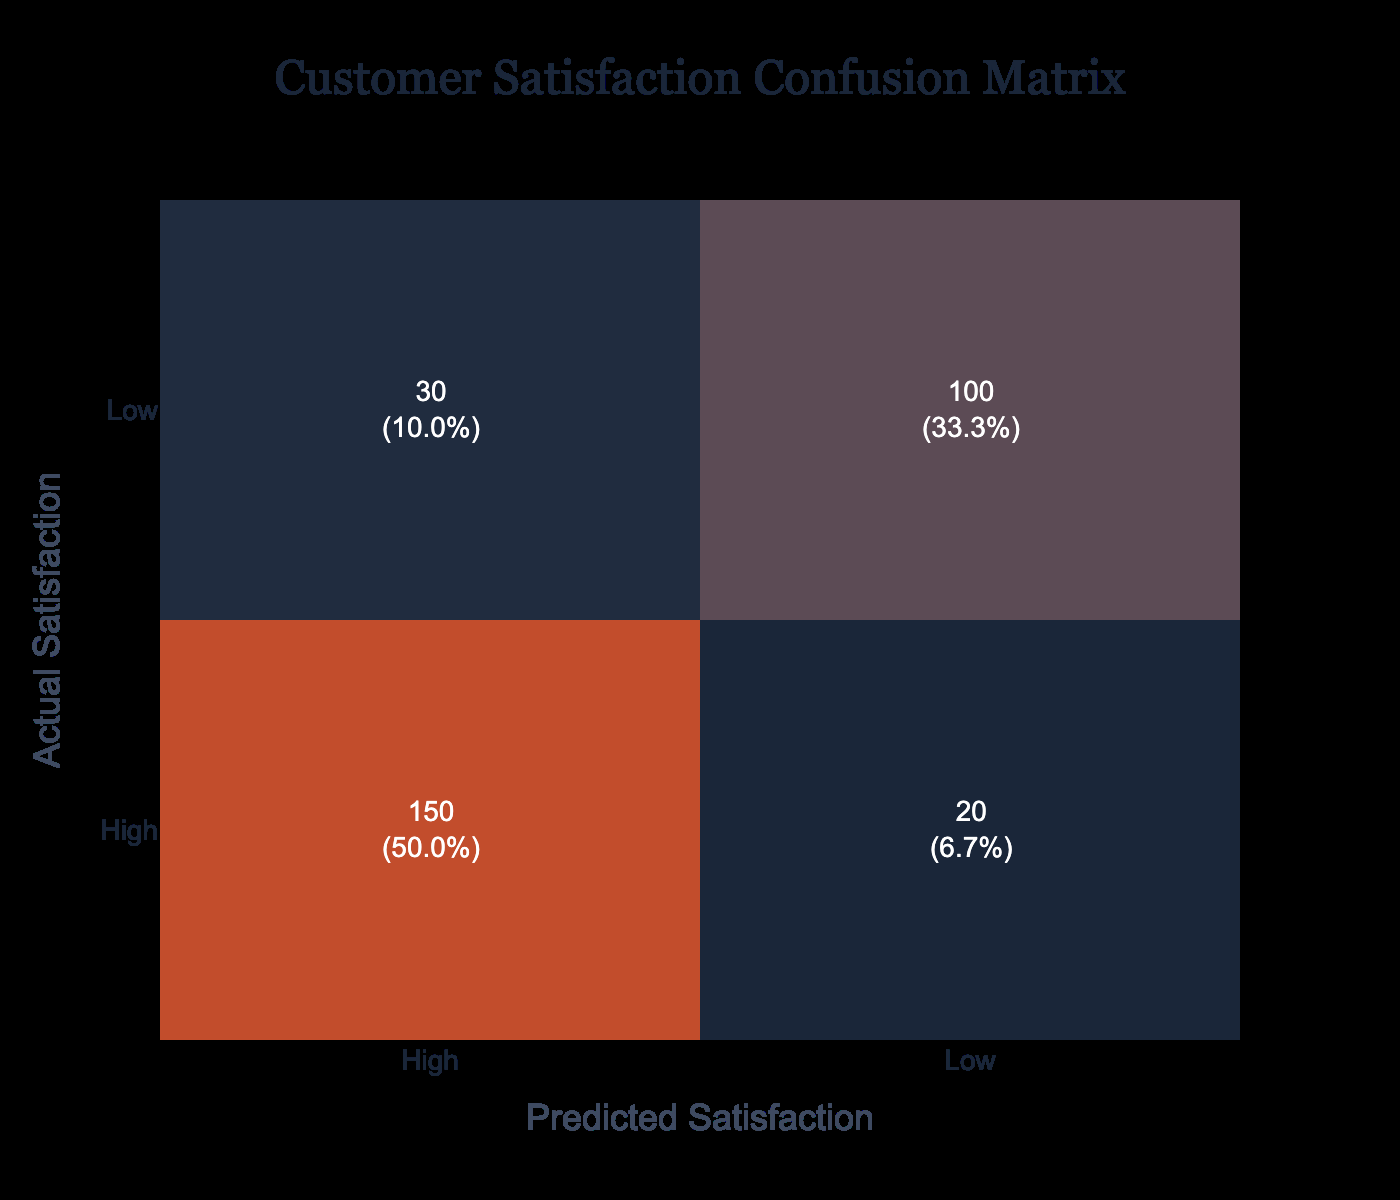What is the total number of customers surveyed? To find the total number of customers surveyed, we need to sum the counts from all the categories in the table: 150 (High, High) + 30 (High, Low) + 20 (Low, High) + 100 (Low, Low) = 300.
Answer: 300 How many customers predicted a Low satisfaction but actually had High satisfaction? Looking at the table, we see that the count for customers who predicted Low and actually had High satisfaction is 20.
Answer: 20 What percentage of customers predicted High satisfaction and actually had Low satisfaction? We find that 30 customers predicted High satisfaction but had Low satisfaction. To calculate the percentage, we divide this count (30) by the total number of customers (300), then multiply by 100. The calculation is (30/300) * 100 = 10%.
Answer: 10% Is it true that more customers predicted Low satisfaction than those who actually had High satisfaction? There are 100 customers who predicted Low satisfaction (30 predicted High satisfaction and actually had Low) and 20 customers who actually had High satisfaction (20 predicted Low satisfaction and had High). Since 100 is greater than 20, this statement is true.
Answer: Yes What is the difference in the number of customers between those who predicted High satisfaction and those who actually had Low satisfaction? We have 180 customers predicted High satisfaction (150 with actual High and 30 with actual Low) and 130 customers who actually had Low satisfaction (30 with predicted High and 100 with predicted Low). The difference is 180 - 130 = 50.
Answer: 50 How many customers are in the High, High category compared to the Low, Low category? The count for the High, High category is 150, while the count for the Low, Low category is 100. Therefore, the High, High category has 150 - 100 = 50 more customers than the Low, Low category.
Answer: 50 What is the ratio of customers who predicted Low satisfaction to those who actually had High satisfaction? Customers who predicted Low satisfaction total 120 (30 predicted High and actually had Low + 100 predicted Low and actually had Low). Those who actually had High satisfaction total 170 (150 predicted High and actually had High + 20 predicted Low and actually had High). The ratio of predicted Low satisfaction to actual High satisfaction is 120:170 which simplifies to 12:17.
Answer: 12:17 How many customers did not predict High satisfaction but actually had High satisfaction? To find this, we need to look at the Low, High category, which counts 20 customers. Those who did not predict High satisfaction and actually had High satisfaction total 20.
Answer: 20 